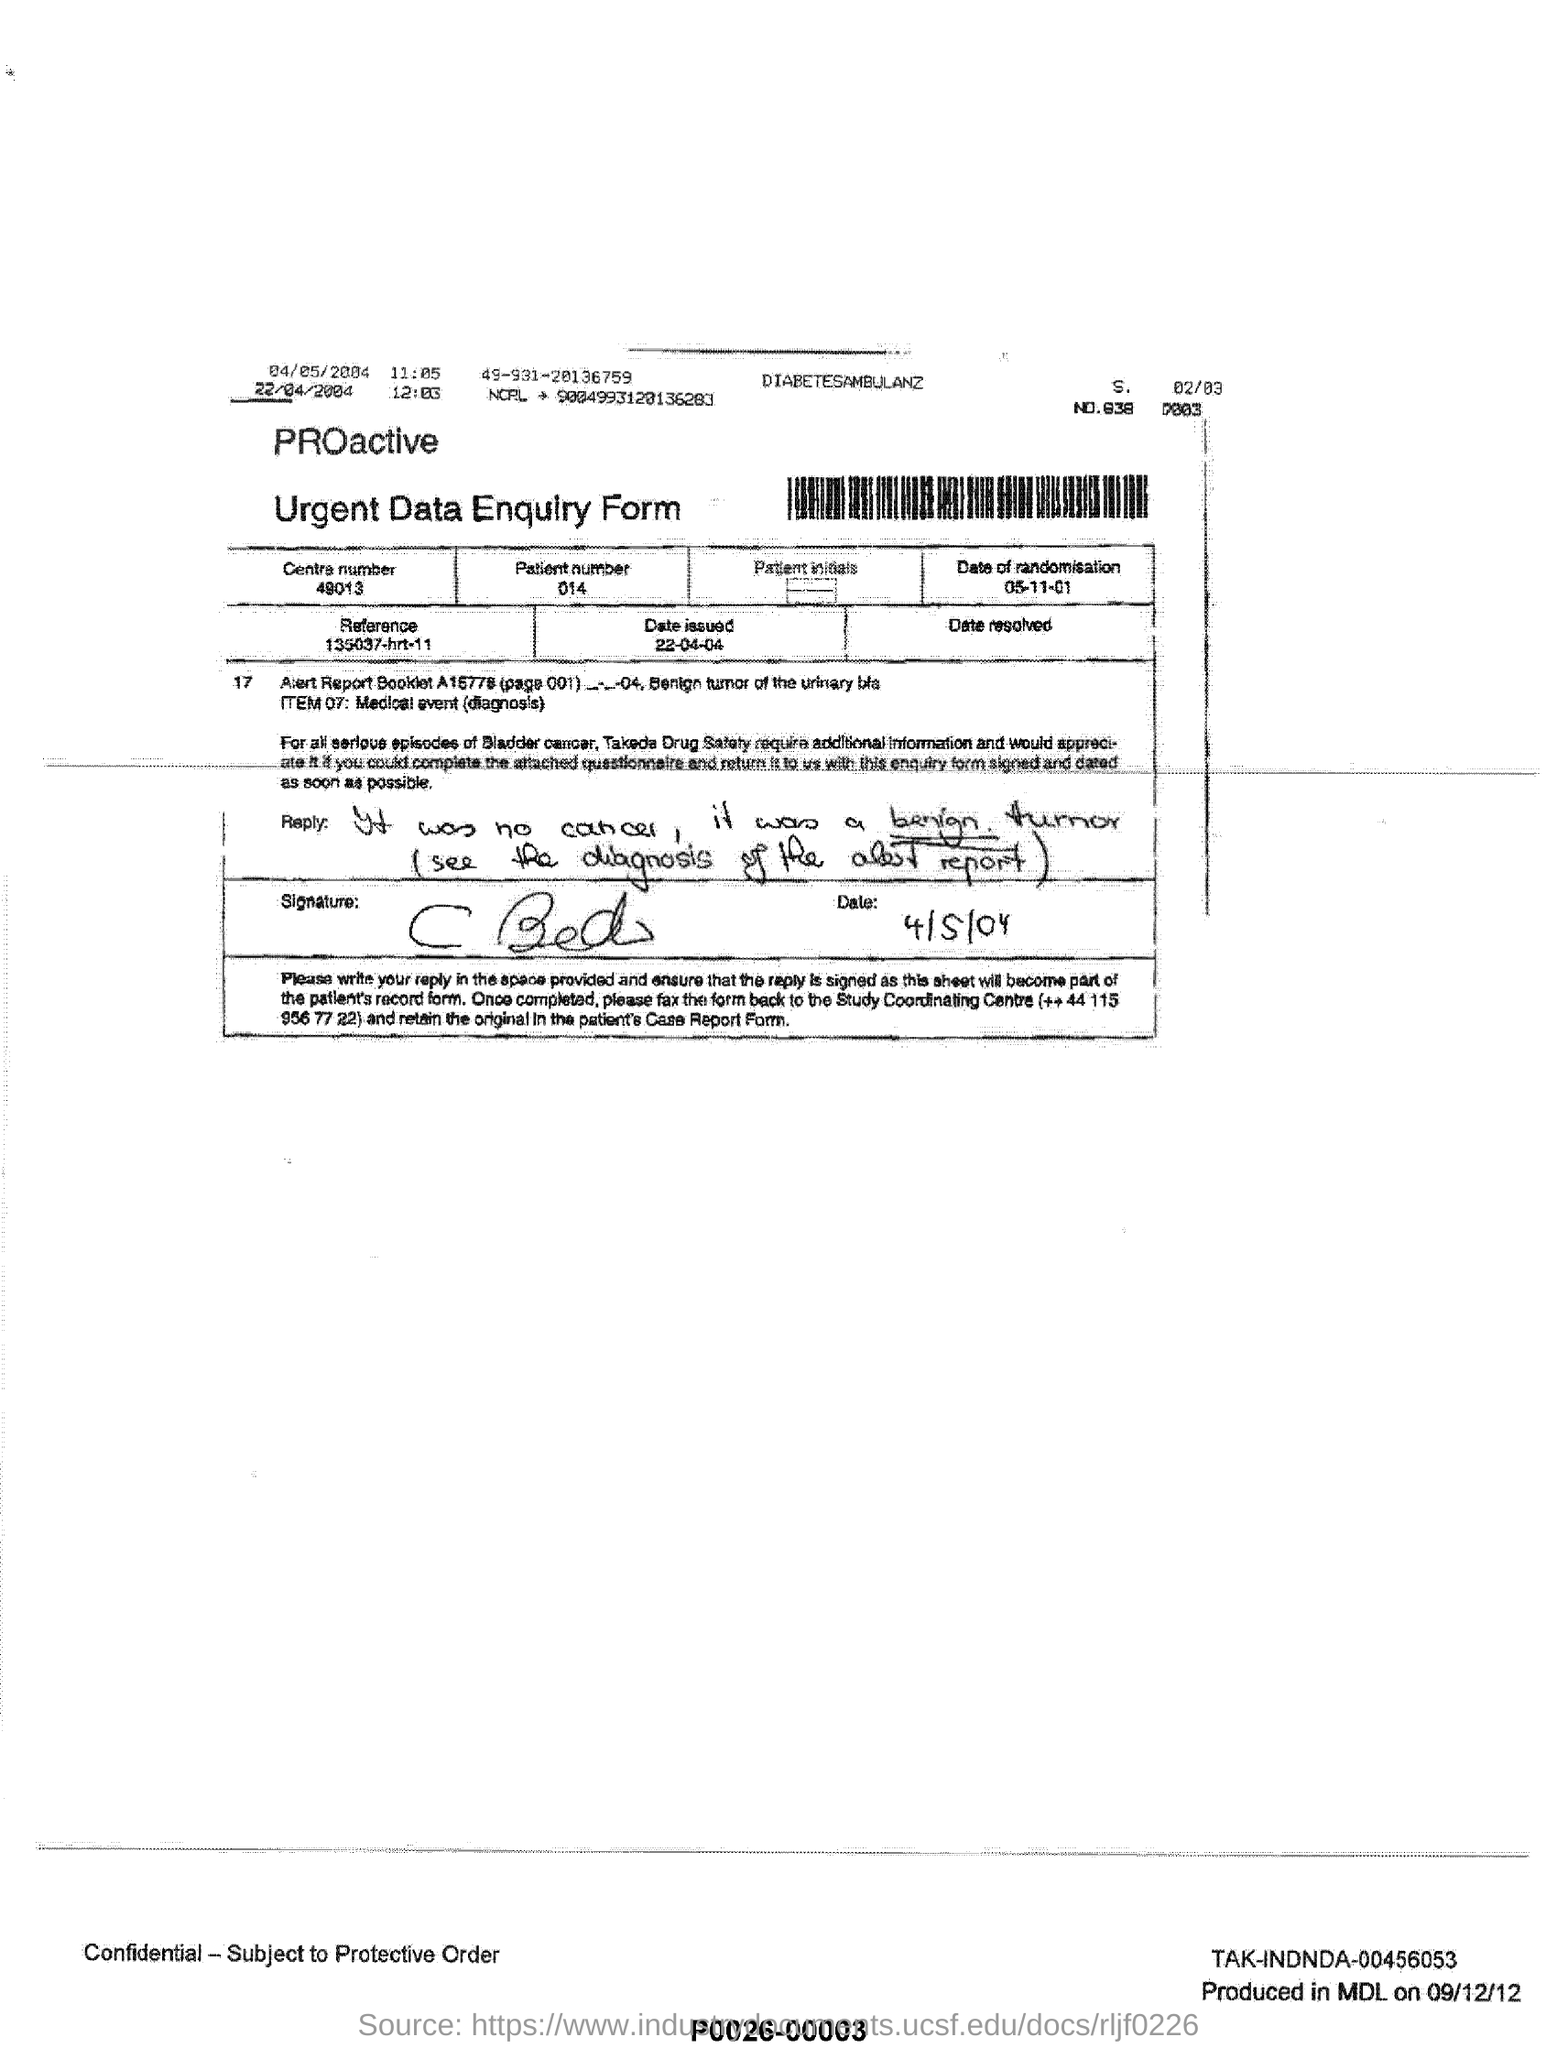Highlight a few significant elements in this photo. The patient number is 014. The Centre number for the phone number 49013... is... The date of randomization is 05/11/01. The reference mentioned is 135037-hrt-11. 